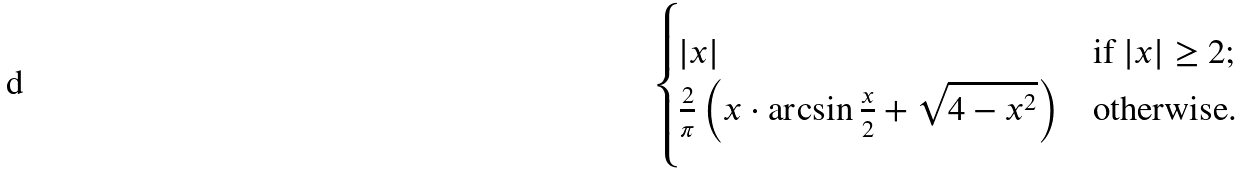Convert formula to latex. <formula><loc_0><loc_0><loc_500><loc_500>\begin{cases} | x | & \text {if } | x | \geq 2 ; \\ \frac { 2 } { \pi } \left ( x \cdot \arcsin \frac { x } { 2 } + \sqrt { 4 - x ^ { 2 } } \right ) & \text {otherwise.} \end{cases}</formula> 